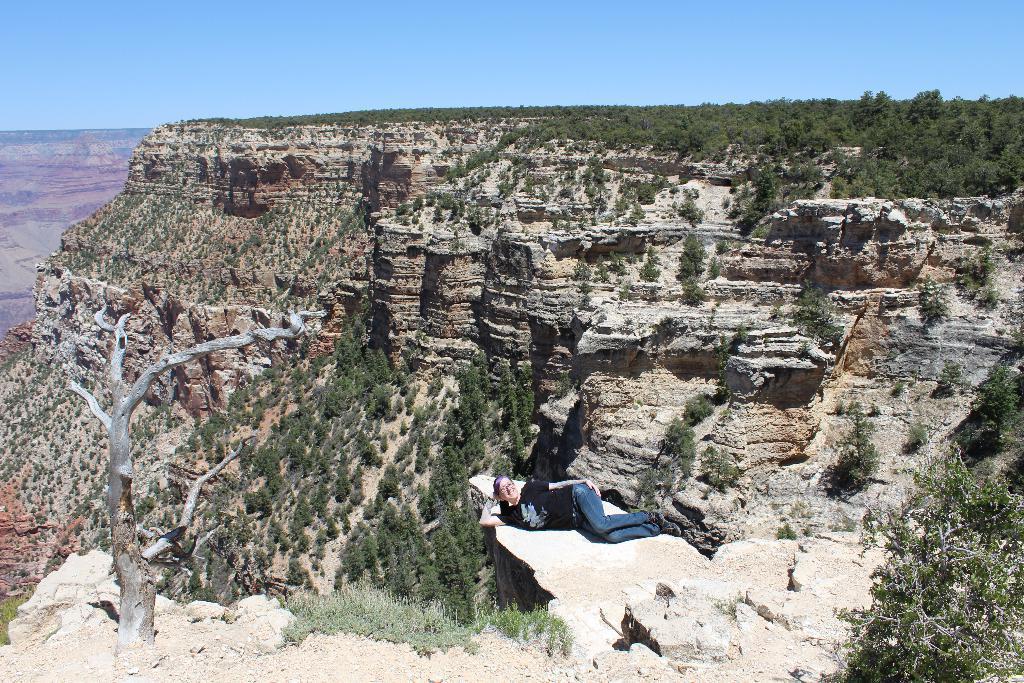How would you summarize this image in a sentence or two? There is a woman in black color t-shirt, smiling and lying on the edge surface of a hill. On the right side, there is a dry tree. On the right side, there is a plant. In the background, there are mountains on which, there are trees and there is blue sky. 